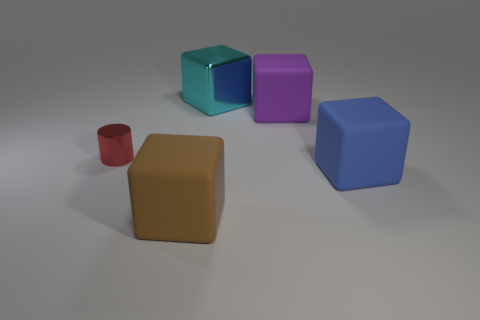What is the color of the big matte object that is behind the matte thing right of the purple cube?
Offer a terse response. Purple. What color is the metal cube that is the same size as the purple rubber cube?
Keep it short and to the point. Cyan. Is there a big purple rubber object of the same shape as the small object?
Offer a terse response. No. What is the shape of the brown thing?
Your answer should be very brief. Cube. Are there more tiny red things that are to the right of the big blue rubber thing than big blue blocks behind the cyan thing?
Your response must be concise. No. What number of other objects are the same size as the purple matte object?
Give a very brief answer. 3. There is a block that is on the left side of the purple matte cube and behind the tiny shiny cylinder; what material is it made of?
Give a very brief answer. Metal. What is the material of the big blue thing that is the same shape as the brown object?
Provide a short and direct response. Rubber. How many metal things are in front of the big cube to the right of the purple matte object that is on the right side of the cyan block?
Your answer should be very brief. 0. Is there anything else that is the same color as the metal cube?
Offer a terse response. No. 